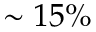<formula> <loc_0><loc_0><loc_500><loc_500>\sim 1 5 \%</formula> 